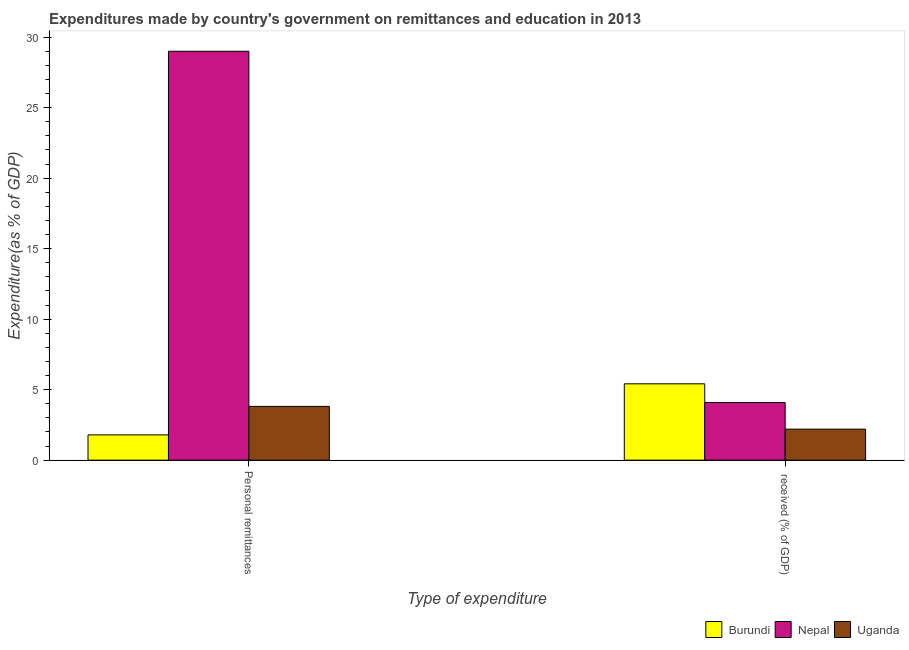How many groups of bars are there?
Your response must be concise. 2. Are the number of bars on each tick of the X-axis equal?
Your answer should be very brief. Yes. How many bars are there on the 2nd tick from the left?
Ensure brevity in your answer.  3. What is the label of the 1st group of bars from the left?
Your response must be concise. Personal remittances. What is the expenditure in personal remittances in Burundi?
Offer a terse response. 1.79. Across all countries, what is the maximum expenditure in personal remittances?
Make the answer very short. 29. Across all countries, what is the minimum expenditure in personal remittances?
Ensure brevity in your answer.  1.79. In which country was the expenditure in education maximum?
Your answer should be very brief. Burundi. In which country was the expenditure in personal remittances minimum?
Offer a very short reply. Burundi. What is the total expenditure in personal remittances in the graph?
Your answer should be very brief. 34.61. What is the difference between the expenditure in personal remittances in Burundi and that in Nepal?
Provide a succinct answer. -27.21. What is the difference between the expenditure in personal remittances in Burundi and the expenditure in education in Nepal?
Provide a short and direct response. -2.3. What is the average expenditure in personal remittances per country?
Provide a short and direct response. 11.54. What is the difference between the expenditure in personal remittances and expenditure in education in Burundi?
Offer a terse response. -3.62. In how many countries, is the expenditure in education greater than 16 %?
Offer a very short reply. 0. What is the ratio of the expenditure in personal remittances in Burundi to that in Nepal?
Offer a terse response. 0.06. Is the expenditure in education in Nepal less than that in Burundi?
Provide a succinct answer. Yes. In how many countries, is the expenditure in personal remittances greater than the average expenditure in personal remittances taken over all countries?
Offer a terse response. 1. What does the 3rd bar from the left in  received (% of GDP) represents?
Make the answer very short. Uganda. What does the 3rd bar from the right in Personal remittances represents?
Your response must be concise. Burundi. Are all the bars in the graph horizontal?
Provide a short and direct response. No. What is the difference between two consecutive major ticks on the Y-axis?
Make the answer very short. 5. Where does the legend appear in the graph?
Provide a short and direct response. Bottom right. How many legend labels are there?
Offer a very short reply. 3. How are the legend labels stacked?
Give a very brief answer. Horizontal. What is the title of the graph?
Give a very brief answer. Expenditures made by country's government on remittances and education in 2013. Does "Benin" appear as one of the legend labels in the graph?
Ensure brevity in your answer.  No. What is the label or title of the X-axis?
Keep it short and to the point. Type of expenditure. What is the label or title of the Y-axis?
Your answer should be very brief. Expenditure(as % of GDP). What is the Expenditure(as % of GDP) of Burundi in Personal remittances?
Your response must be concise. 1.79. What is the Expenditure(as % of GDP) in Nepal in Personal remittances?
Your answer should be compact. 29. What is the Expenditure(as % of GDP) in Uganda in Personal remittances?
Provide a short and direct response. 3.81. What is the Expenditure(as % of GDP) in Burundi in  received (% of GDP)?
Provide a succinct answer. 5.41. What is the Expenditure(as % of GDP) in Nepal in  received (% of GDP)?
Offer a very short reply. 4.09. What is the Expenditure(as % of GDP) in Uganda in  received (% of GDP)?
Keep it short and to the point. 2.2. Across all Type of expenditure, what is the maximum Expenditure(as % of GDP) of Burundi?
Your answer should be compact. 5.41. Across all Type of expenditure, what is the maximum Expenditure(as % of GDP) of Nepal?
Keep it short and to the point. 29. Across all Type of expenditure, what is the maximum Expenditure(as % of GDP) in Uganda?
Provide a short and direct response. 3.81. Across all Type of expenditure, what is the minimum Expenditure(as % of GDP) in Burundi?
Provide a short and direct response. 1.79. Across all Type of expenditure, what is the minimum Expenditure(as % of GDP) of Nepal?
Provide a succinct answer. 4.09. Across all Type of expenditure, what is the minimum Expenditure(as % of GDP) of Uganda?
Make the answer very short. 2.2. What is the total Expenditure(as % of GDP) in Burundi in the graph?
Make the answer very short. 7.21. What is the total Expenditure(as % of GDP) of Nepal in the graph?
Offer a very short reply. 33.09. What is the total Expenditure(as % of GDP) in Uganda in the graph?
Your response must be concise. 6.01. What is the difference between the Expenditure(as % of GDP) in Burundi in Personal remittances and that in  received (% of GDP)?
Provide a short and direct response. -3.62. What is the difference between the Expenditure(as % of GDP) of Nepal in Personal remittances and that in  received (% of GDP)?
Give a very brief answer. 24.91. What is the difference between the Expenditure(as % of GDP) in Uganda in Personal remittances and that in  received (% of GDP)?
Offer a terse response. 1.61. What is the difference between the Expenditure(as % of GDP) of Burundi in Personal remittances and the Expenditure(as % of GDP) of Nepal in  received (% of GDP)?
Your answer should be very brief. -2.3. What is the difference between the Expenditure(as % of GDP) of Burundi in Personal remittances and the Expenditure(as % of GDP) of Uganda in  received (% of GDP)?
Offer a terse response. -0.41. What is the difference between the Expenditure(as % of GDP) in Nepal in Personal remittances and the Expenditure(as % of GDP) in Uganda in  received (% of GDP)?
Provide a succinct answer. 26.8. What is the average Expenditure(as % of GDP) of Burundi per Type of expenditure?
Your answer should be compact. 3.6. What is the average Expenditure(as % of GDP) in Nepal per Type of expenditure?
Give a very brief answer. 16.54. What is the average Expenditure(as % of GDP) of Uganda per Type of expenditure?
Make the answer very short. 3.01. What is the difference between the Expenditure(as % of GDP) in Burundi and Expenditure(as % of GDP) in Nepal in Personal remittances?
Offer a terse response. -27.21. What is the difference between the Expenditure(as % of GDP) in Burundi and Expenditure(as % of GDP) in Uganda in Personal remittances?
Provide a succinct answer. -2.02. What is the difference between the Expenditure(as % of GDP) of Nepal and Expenditure(as % of GDP) of Uganda in Personal remittances?
Provide a succinct answer. 25.19. What is the difference between the Expenditure(as % of GDP) of Burundi and Expenditure(as % of GDP) of Nepal in  received (% of GDP)?
Offer a terse response. 1.33. What is the difference between the Expenditure(as % of GDP) in Burundi and Expenditure(as % of GDP) in Uganda in  received (% of GDP)?
Your answer should be very brief. 3.21. What is the difference between the Expenditure(as % of GDP) of Nepal and Expenditure(as % of GDP) of Uganda in  received (% of GDP)?
Ensure brevity in your answer.  1.89. What is the ratio of the Expenditure(as % of GDP) in Burundi in Personal remittances to that in  received (% of GDP)?
Your response must be concise. 0.33. What is the ratio of the Expenditure(as % of GDP) in Nepal in Personal remittances to that in  received (% of GDP)?
Your response must be concise. 7.1. What is the ratio of the Expenditure(as % of GDP) in Uganda in Personal remittances to that in  received (% of GDP)?
Offer a very short reply. 1.73. What is the difference between the highest and the second highest Expenditure(as % of GDP) of Burundi?
Make the answer very short. 3.62. What is the difference between the highest and the second highest Expenditure(as % of GDP) in Nepal?
Your answer should be very brief. 24.91. What is the difference between the highest and the second highest Expenditure(as % of GDP) of Uganda?
Provide a succinct answer. 1.61. What is the difference between the highest and the lowest Expenditure(as % of GDP) in Burundi?
Your response must be concise. 3.62. What is the difference between the highest and the lowest Expenditure(as % of GDP) in Nepal?
Offer a very short reply. 24.91. What is the difference between the highest and the lowest Expenditure(as % of GDP) of Uganda?
Provide a short and direct response. 1.61. 